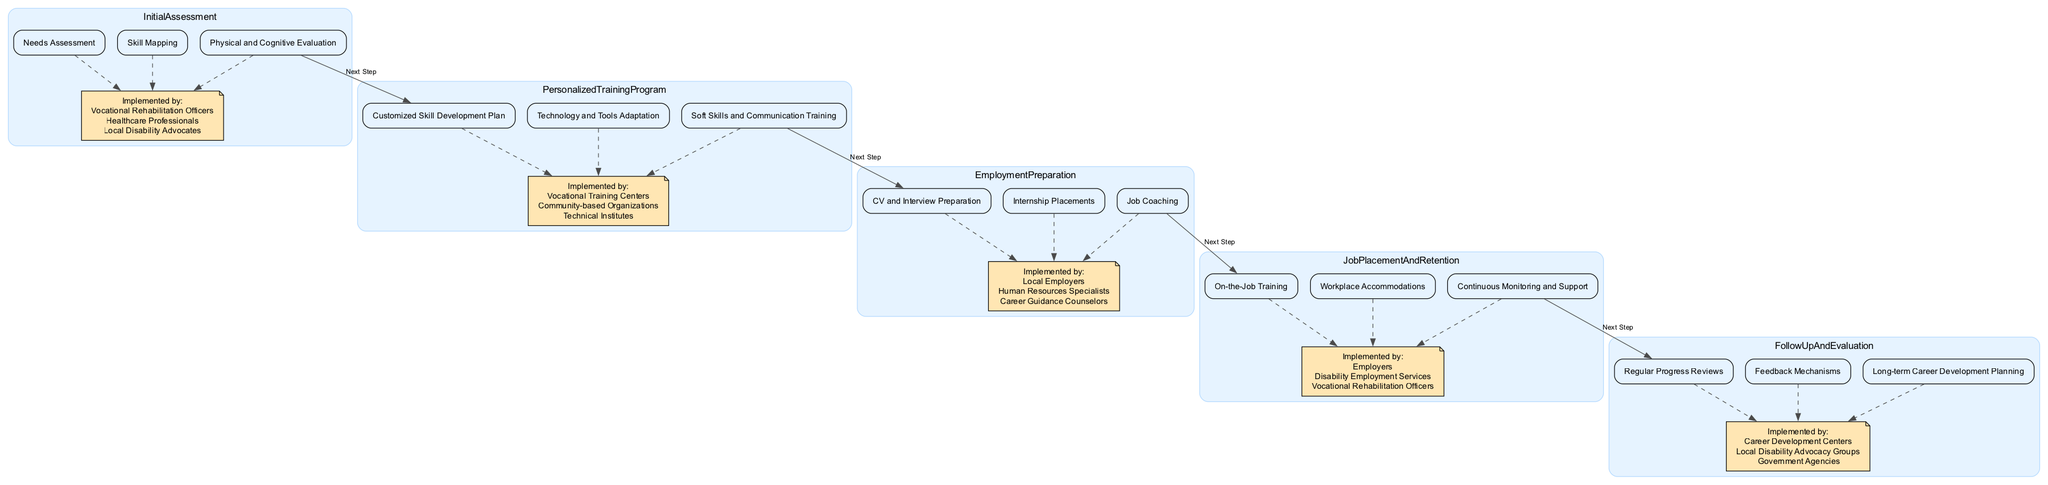What are the components of the Initial Assessment? The diagram shows that the components of the Initial Assessment are Needs Assessment, Skill Mapping, and Physical and Cognitive Evaluation.
Answer: Needs Assessment, Skill Mapping, Physical and Cognitive Evaluation Who implements the Job Placement and Retention step? The diagram indicates that the Job Placement and Retention step is implemented by Employers, Disability Employment Services, and Vocational Rehabilitation Officers.
Answer: Employers, Disability Employment Services, Vocational Rehabilitation Officers How many main steps are there in the pathway? By counting the distinct main steps in the diagram, we see five: Initial Assessment, Personalized Training Program, Employment Preparation, Job Placement and Retention, and Follow Up and Evaluation.
Answer: 5 What connects Employment Preparation to the next step? The diagram shows that Employment Preparation is connected to Job Placement and Retention by the edge labeled "Next Step."
Answer: Next Step What follows after Personalized Training Program? The diagram indicates that the next step after Personalized Training Program is Employment Preparation.
Answer: Employment Preparation Which components are included in Job Placement and Retention? The Job Placement and Retention section includes On-the-Job Training, Workplace Accommodations, and Continuous Monitoring and Support as its components.
Answer: On-the-Job Training, Workplace Accommodations, Continuous Monitoring and Support What type of organizations implement the Personalized Training Program? The diagram shows that Personalized Training Program is implemented by Vocational Training Centers, Community-based Organizations, and Technical Institutes.
Answer: Vocational Training Centers, Community-based Organizations, Technical Institutes What feedback methods are involved in Follow Up and Evaluation? The Follow Up and Evaluation step includes Regular Progress Reviews, Feedback Mechanisms, and Long-term Career Development Planning as its components.
Answer: Regular Progress Reviews, Feedback Mechanisms, Long-term Career Development Planning Which node has a dashed connection from all components of Initial Assessment? The shared dashed connection comes from all components of Initial Assessment towards the node labeled "Implemented by: Vocational Rehabilitation Officers, Healthcare Professionals, Local Disability Advocates."
Answer: Implemented by: Vocational Rehabilitation Officers, Healthcare Professionals, Local Disability Advocates 